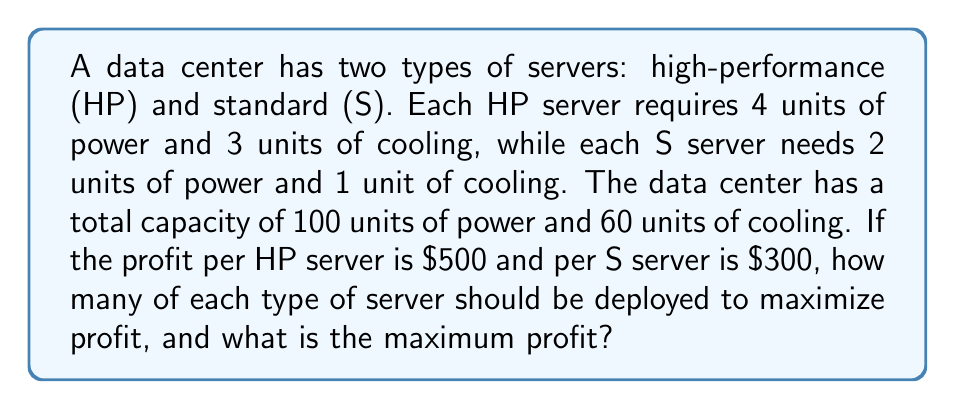Show me your answer to this math problem. Let's approach this step-by-step:

1) Define variables:
   Let $x$ = number of HP servers
   Let $y$ = number of S servers

2) Set up the objective function (profit):
   Maximize $P = 500x + 300y$

3) Establish constraints:
   Power constraint: $4x + 2y \leq 100$
   Cooling constraint: $3x + y \leq 60$
   Non-negativity: $x \geq 0, y \geq 0$

4) Graph the constraints:
   [asy]
   import geometry;
   
   size(200);
   
   xaxis("HP Servers (x)", 0, 30, Arrow);
   yaxis("Standard Servers (y)", 0, 60, Arrow);
   
   draw((0,50)--(25,0), blue);
   draw((0,60)--(20,0), red);
   
   label("4x + 2y = 100", (12,25), blue);
   label("3x + y = 60", (10,30), red);
   
   fill((0,0)--(0,60)--(20,0)--cycle, gray(0.9));
   
   dot((0,50));
   dot((25,0));
   dot((0,60));
   dot((20,0));
   dot((15,15));
   
   label("(15,15)", (15,15), SE);
   [/asy]

5) Identify the corner points of the feasible region:
   (0,0), (0,60), (20,0), and the intersection point of the two constraints.

6) Find the intersection point by solving:
   $4x + 2y = 100$
   $3x + y = 60$
   
   Multiply the second equation by 2:
   $4x + 2y = 100$
   $6x + 2y = 120$
   
   Subtracting:
   $-2x = -20$
   $x = 15$
   
   Substitute back:
   $3(15) + y = 60$
   $45 + y = 60$
   $y = 15$
   
   So the intersection point is (15, 15).

7) Evaluate the profit function at each corner point:
   (0,0): $P = 0$
   (0,60): $P = 18,000$
   (20,0): $P = 10,000$
   (15,15): $P = 500(15) + 300(15) = 7,500 + 4,500 = 12,000$

8) The maximum profit occurs at (15, 15), which means 15 HP servers and 15 S servers.
Answer: 15 HP servers, 15 S servers; $12,000 maximum profit 